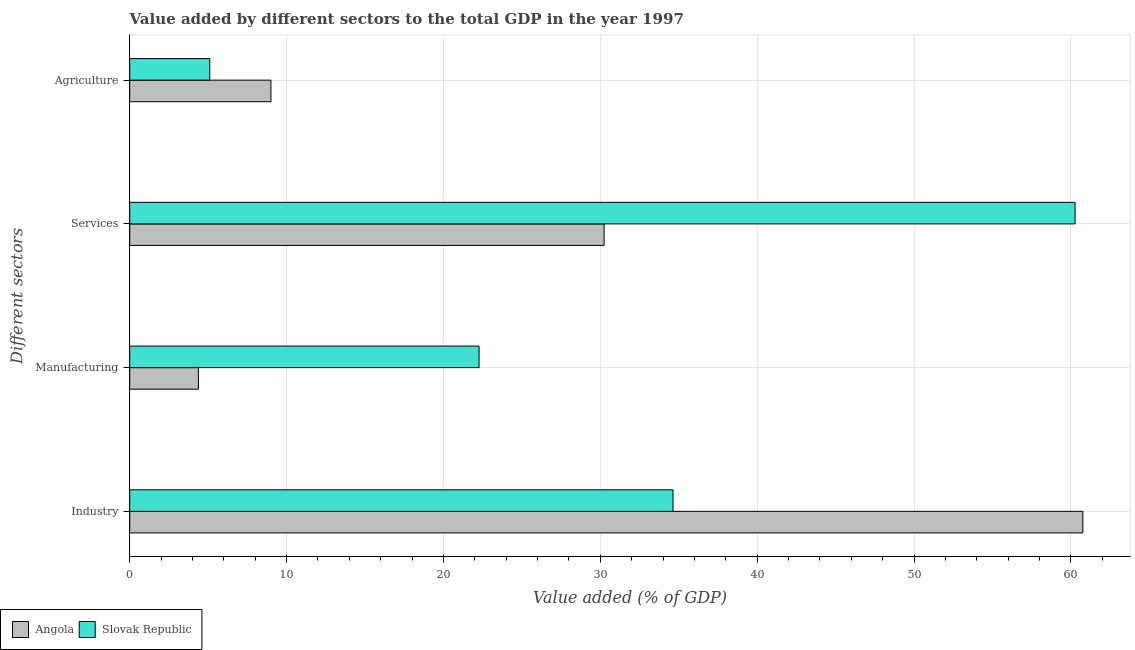How many groups of bars are there?
Offer a terse response. 4. Are the number of bars per tick equal to the number of legend labels?
Make the answer very short. Yes. Are the number of bars on each tick of the Y-axis equal?
Your answer should be compact. Yes. How many bars are there on the 3rd tick from the top?
Your answer should be very brief. 2. What is the label of the 1st group of bars from the top?
Your response must be concise. Agriculture. What is the value added by manufacturing sector in Slovak Republic?
Offer a very short reply. 22.27. Across all countries, what is the maximum value added by services sector?
Your response must be concise. 60.26. Across all countries, what is the minimum value added by services sector?
Offer a terse response. 30.24. In which country was the value added by manufacturing sector maximum?
Your answer should be very brief. Slovak Republic. In which country was the value added by industrial sector minimum?
Make the answer very short. Slovak Republic. What is the total value added by agricultural sector in the graph?
Your answer should be compact. 14.1. What is the difference between the value added by agricultural sector in Slovak Republic and that in Angola?
Ensure brevity in your answer.  -3.9. What is the difference between the value added by agricultural sector in Angola and the value added by industrial sector in Slovak Republic?
Provide a short and direct response. -25.63. What is the average value added by services sector per country?
Ensure brevity in your answer.  45.25. What is the difference between the value added by industrial sector and value added by manufacturing sector in Angola?
Ensure brevity in your answer.  56.38. In how many countries, is the value added by industrial sector greater than 24 %?
Your answer should be very brief. 2. What is the ratio of the value added by industrial sector in Angola to that in Slovak Republic?
Your answer should be very brief. 1.75. Is the difference between the value added by industrial sector in Slovak Republic and Angola greater than the difference between the value added by manufacturing sector in Slovak Republic and Angola?
Your answer should be compact. No. What is the difference between the highest and the second highest value added by services sector?
Your answer should be very brief. 30.02. What is the difference between the highest and the lowest value added by agricultural sector?
Make the answer very short. 3.9. What does the 2nd bar from the top in Services represents?
Your response must be concise. Angola. What does the 1st bar from the bottom in Services represents?
Offer a very short reply. Angola. Is it the case that in every country, the sum of the value added by industrial sector and value added by manufacturing sector is greater than the value added by services sector?
Offer a terse response. No. How many countries are there in the graph?
Make the answer very short. 2. What is the difference between two consecutive major ticks on the X-axis?
Give a very brief answer. 10. Are the values on the major ticks of X-axis written in scientific E-notation?
Your answer should be very brief. No. Does the graph contain any zero values?
Offer a terse response. No. Does the graph contain grids?
Ensure brevity in your answer.  Yes. How many legend labels are there?
Offer a very short reply. 2. How are the legend labels stacked?
Make the answer very short. Horizontal. What is the title of the graph?
Offer a terse response. Value added by different sectors to the total GDP in the year 1997. What is the label or title of the X-axis?
Offer a terse response. Value added (% of GDP). What is the label or title of the Y-axis?
Your response must be concise. Different sectors. What is the Value added (% of GDP) of Angola in Industry?
Your response must be concise. 60.76. What is the Value added (% of GDP) of Slovak Republic in Industry?
Give a very brief answer. 34.63. What is the Value added (% of GDP) in Angola in Manufacturing?
Offer a terse response. 4.38. What is the Value added (% of GDP) of Slovak Republic in Manufacturing?
Offer a terse response. 22.27. What is the Value added (% of GDP) in Angola in Services?
Ensure brevity in your answer.  30.24. What is the Value added (% of GDP) in Slovak Republic in Services?
Keep it short and to the point. 60.26. What is the Value added (% of GDP) in Angola in Agriculture?
Offer a very short reply. 9. What is the Value added (% of GDP) in Slovak Republic in Agriculture?
Your response must be concise. 5.1. Across all Different sectors, what is the maximum Value added (% of GDP) of Angola?
Keep it short and to the point. 60.76. Across all Different sectors, what is the maximum Value added (% of GDP) in Slovak Republic?
Your response must be concise. 60.26. Across all Different sectors, what is the minimum Value added (% of GDP) of Angola?
Keep it short and to the point. 4.38. Across all Different sectors, what is the minimum Value added (% of GDP) in Slovak Republic?
Keep it short and to the point. 5.1. What is the total Value added (% of GDP) in Angola in the graph?
Provide a succinct answer. 104.38. What is the total Value added (% of GDP) of Slovak Republic in the graph?
Offer a very short reply. 122.27. What is the difference between the Value added (% of GDP) in Angola in Industry and that in Manufacturing?
Offer a terse response. 56.38. What is the difference between the Value added (% of GDP) in Slovak Republic in Industry and that in Manufacturing?
Provide a short and direct response. 12.36. What is the difference between the Value added (% of GDP) of Angola in Industry and that in Services?
Offer a very short reply. 30.52. What is the difference between the Value added (% of GDP) in Slovak Republic in Industry and that in Services?
Provide a succinct answer. -25.63. What is the difference between the Value added (% of GDP) in Angola in Industry and that in Agriculture?
Offer a very short reply. 51.76. What is the difference between the Value added (% of GDP) of Slovak Republic in Industry and that in Agriculture?
Give a very brief answer. 29.53. What is the difference between the Value added (% of GDP) of Angola in Manufacturing and that in Services?
Offer a terse response. -25.86. What is the difference between the Value added (% of GDP) of Slovak Republic in Manufacturing and that in Services?
Your response must be concise. -37.99. What is the difference between the Value added (% of GDP) in Angola in Manufacturing and that in Agriculture?
Provide a short and direct response. -4.62. What is the difference between the Value added (% of GDP) of Slovak Republic in Manufacturing and that in Agriculture?
Your response must be concise. 17.17. What is the difference between the Value added (% of GDP) in Angola in Services and that in Agriculture?
Offer a very short reply. 21.24. What is the difference between the Value added (% of GDP) of Slovak Republic in Services and that in Agriculture?
Your answer should be compact. 55.16. What is the difference between the Value added (% of GDP) in Angola in Industry and the Value added (% of GDP) in Slovak Republic in Manufacturing?
Offer a very short reply. 38.49. What is the difference between the Value added (% of GDP) in Angola in Industry and the Value added (% of GDP) in Slovak Republic in Services?
Offer a very short reply. 0.49. What is the difference between the Value added (% of GDP) of Angola in Industry and the Value added (% of GDP) of Slovak Republic in Agriculture?
Your answer should be compact. 55.66. What is the difference between the Value added (% of GDP) of Angola in Manufacturing and the Value added (% of GDP) of Slovak Republic in Services?
Your answer should be very brief. -55.89. What is the difference between the Value added (% of GDP) of Angola in Manufacturing and the Value added (% of GDP) of Slovak Republic in Agriculture?
Offer a very short reply. -0.72. What is the difference between the Value added (% of GDP) of Angola in Services and the Value added (% of GDP) of Slovak Republic in Agriculture?
Offer a terse response. 25.14. What is the average Value added (% of GDP) in Angola per Different sectors?
Keep it short and to the point. 26.09. What is the average Value added (% of GDP) of Slovak Republic per Different sectors?
Keep it short and to the point. 30.57. What is the difference between the Value added (% of GDP) of Angola and Value added (% of GDP) of Slovak Republic in Industry?
Your response must be concise. 26.12. What is the difference between the Value added (% of GDP) in Angola and Value added (% of GDP) in Slovak Republic in Manufacturing?
Provide a succinct answer. -17.89. What is the difference between the Value added (% of GDP) in Angola and Value added (% of GDP) in Slovak Republic in Services?
Provide a succinct answer. -30.02. What is the difference between the Value added (% of GDP) in Angola and Value added (% of GDP) in Slovak Republic in Agriculture?
Keep it short and to the point. 3.9. What is the ratio of the Value added (% of GDP) in Angola in Industry to that in Manufacturing?
Your answer should be very brief. 13.88. What is the ratio of the Value added (% of GDP) of Slovak Republic in Industry to that in Manufacturing?
Provide a short and direct response. 1.56. What is the ratio of the Value added (% of GDP) of Angola in Industry to that in Services?
Your answer should be very brief. 2.01. What is the ratio of the Value added (% of GDP) of Slovak Republic in Industry to that in Services?
Ensure brevity in your answer.  0.57. What is the ratio of the Value added (% of GDP) in Angola in Industry to that in Agriculture?
Your answer should be compact. 6.75. What is the ratio of the Value added (% of GDP) in Slovak Republic in Industry to that in Agriculture?
Offer a very short reply. 6.79. What is the ratio of the Value added (% of GDP) in Angola in Manufacturing to that in Services?
Your answer should be compact. 0.14. What is the ratio of the Value added (% of GDP) in Slovak Republic in Manufacturing to that in Services?
Keep it short and to the point. 0.37. What is the ratio of the Value added (% of GDP) of Angola in Manufacturing to that in Agriculture?
Ensure brevity in your answer.  0.49. What is the ratio of the Value added (% of GDP) in Slovak Republic in Manufacturing to that in Agriculture?
Offer a terse response. 4.36. What is the ratio of the Value added (% of GDP) of Angola in Services to that in Agriculture?
Your answer should be very brief. 3.36. What is the ratio of the Value added (% of GDP) of Slovak Republic in Services to that in Agriculture?
Your answer should be compact. 11.81. What is the difference between the highest and the second highest Value added (% of GDP) of Angola?
Your answer should be compact. 30.52. What is the difference between the highest and the second highest Value added (% of GDP) in Slovak Republic?
Make the answer very short. 25.63. What is the difference between the highest and the lowest Value added (% of GDP) in Angola?
Provide a short and direct response. 56.38. What is the difference between the highest and the lowest Value added (% of GDP) of Slovak Republic?
Your answer should be very brief. 55.16. 